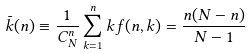<formula> <loc_0><loc_0><loc_500><loc_500>\bar { k } ( n ) \equiv \frac { 1 } { C _ { N } ^ { n } } \sum _ { k = 1 } ^ { n } k f ( n , k ) = \frac { n ( N - n ) } { N - 1 }</formula> 